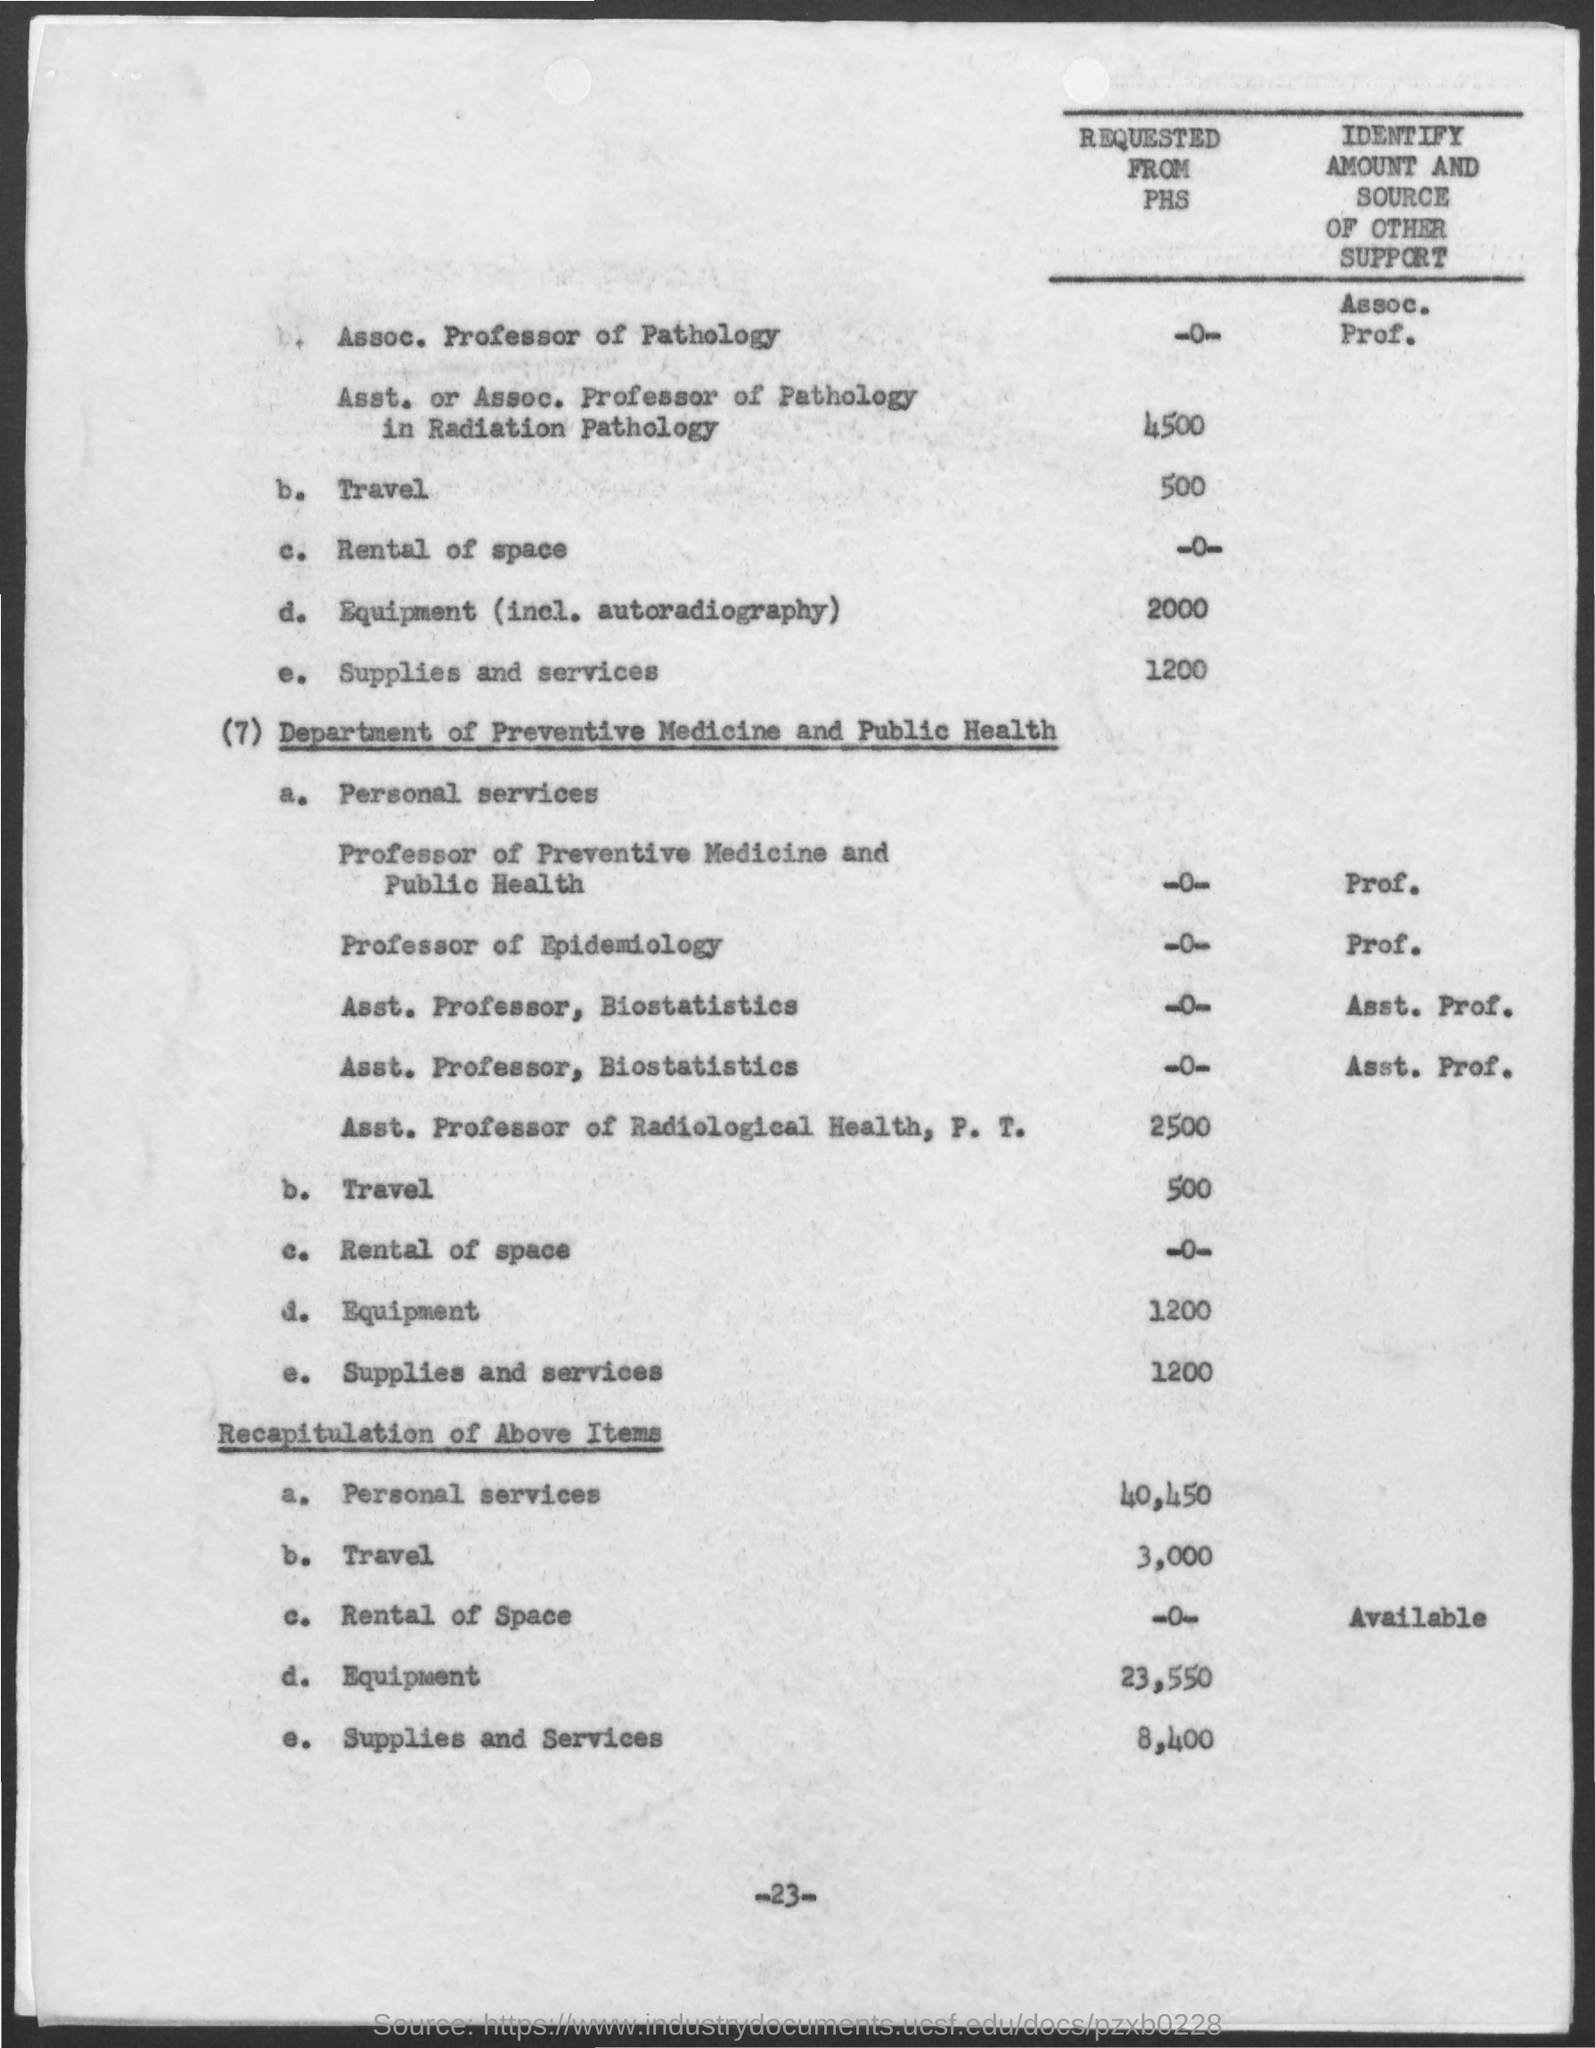Specify some key components in this picture. The page number is 23. 